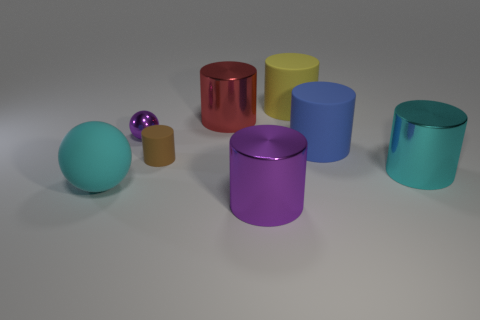What number of brown things are either metal things or rubber spheres?
Give a very brief answer. 0. What number of other objects are there of the same material as the large red thing?
Your response must be concise. 3. There is a purple metal object that is to the right of the tiny purple object; is its shape the same as the big cyan metal thing?
Your answer should be compact. Yes. Are any brown metal spheres visible?
Offer a very short reply. No. Is there any other thing that has the same shape as the small matte thing?
Your answer should be compact. Yes. Is the number of large matte objects on the left side of the tiny rubber object greater than the number of large gray rubber spheres?
Your answer should be very brief. Yes. Are there any things behind the red cylinder?
Make the answer very short. Yes. Do the purple cylinder and the brown matte cylinder have the same size?
Provide a succinct answer. No. What is the size of the cyan metallic thing that is the same shape as the brown rubber thing?
Provide a succinct answer. Large. Is there anything else that is the same size as the red metal cylinder?
Your response must be concise. Yes. 